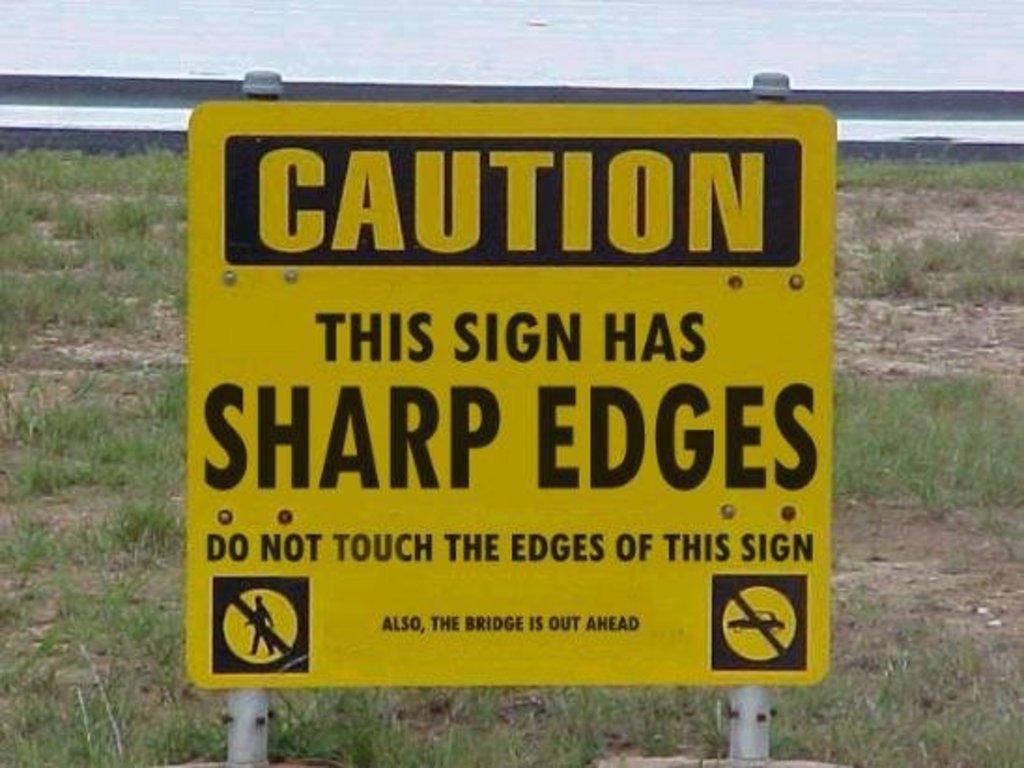What are you not supposed to touch?
Ensure brevity in your answer.  Edges of this sign. 